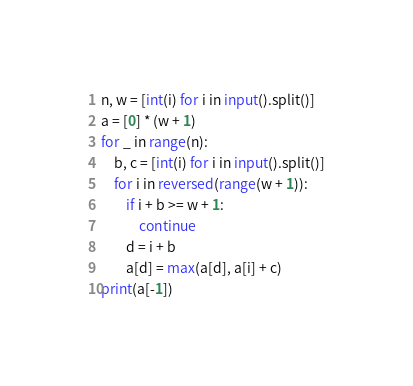Convert code to text. <code><loc_0><loc_0><loc_500><loc_500><_Python_>n, w = [int(i) for i in input().split()]
a = [0] * (w + 1)
for _ in range(n):
    b, c = [int(i) for i in input().split()]
    for i in reversed(range(w + 1)):
        if i + b >= w + 1:
            continue
        d = i + b
        a[d] = max(a[d], a[i] + c)
print(a[-1])
</code> 